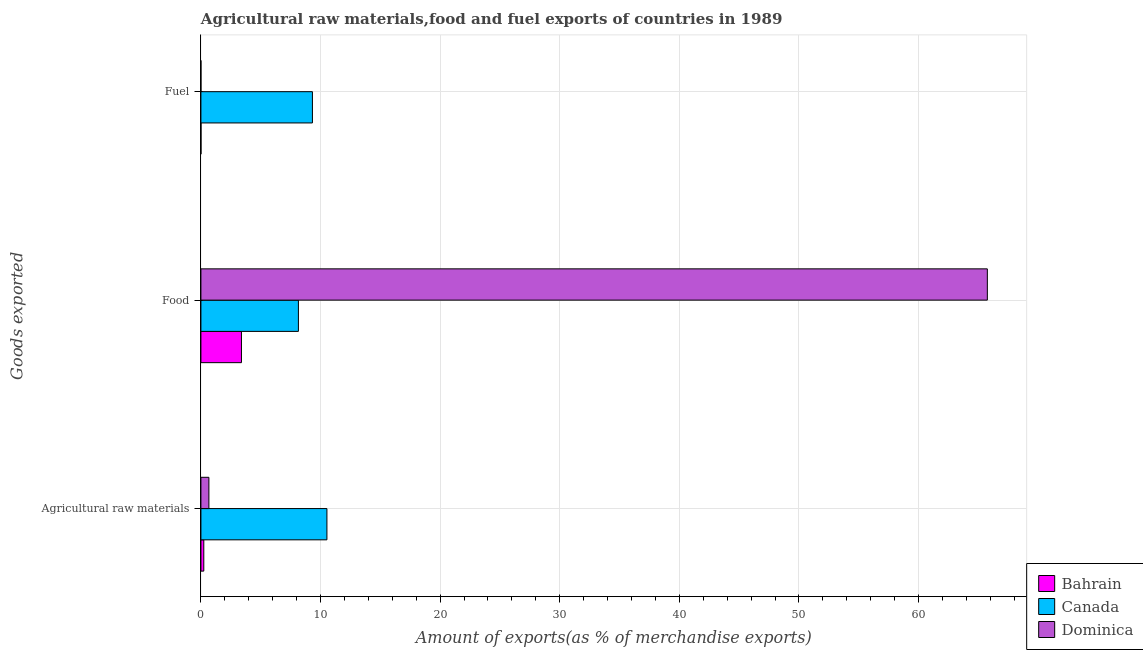How many different coloured bars are there?
Your answer should be very brief. 3. How many groups of bars are there?
Your answer should be compact. 3. What is the label of the 2nd group of bars from the top?
Provide a succinct answer. Food. What is the percentage of raw materials exports in Bahrain?
Your answer should be very brief. 0.24. Across all countries, what is the maximum percentage of fuel exports?
Ensure brevity in your answer.  9.32. Across all countries, what is the minimum percentage of raw materials exports?
Offer a terse response. 0.24. In which country was the percentage of fuel exports maximum?
Offer a terse response. Canada. In which country was the percentage of raw materials exports minimum?
Offer a very short reply. Bahrain. What is the total percentage of raw materials exports in the graph?
Your response must be concise. 11.44. What is the difference between the percentage of raw materials exports in Dominica and that in Bahrain?
Provide a short and direct response. 0.43. What is the difference between the percentage of fuel exports in Canada and the percentage of food exports in Bahrain?
Offer a very short reply. 5.93. What is the average percentage of raw materials exports per country?
Your response must be concise. 3.81. What is the difference between the percentage of fuel exports and percentage of food exports in Canada?
Make the answer very short. 1.17. What is the ratio of the percentage of food exports in Dominica to that in Canada?
Your answer should be compact. 8.07. Is the difference between the percentage of raw materials exports in Dominica and Canada greater than the difference between the percentage of fuel exports in Dominica and Canada?
Provide a short and direct response. No. What is the difference between the highest and the second highest percentage of food exports?
Offer a very short reply. 57.6. What is the difference between the highest and the lowest percentage of fuel exports?
Provide a succinct answer. 9.32. Is the sum of the percentage of fuel exports in Dominica and Bahrain greater than the maximum percentage of food exports across all countries?
Your answer should be very brief. No. What does the 3rd bar from the top in Food represents?
Keep it short and to the point. Bahrain. What does the 2nd bar from the bottom in Fuel represents?
Your answer should be very brief. Canada. Is it the case that in every country, the sum of the percentage of raw materials exports and percentage of food exports is greater than the percentage of fuel exports?
Ensure brevity in your answer.  Yes. How many countries are there in the graph?
Your response must be concise. 3. What is the difference between two consecutive major ticks on the X-axis?
Your response must be concise. 10. Are the values on the major ticks of X-axis written in scientific E-notation?
Keep it short and to the point. No. Does the graph contain grids?
Ensure brevity in your answer.  Yes. Where does the legend appear in the graph?
Give a very brief answer. Bottom right. How are the legend labels stacked?
Give a very brief answer. Vertical. What is the title of the graph?
Your answer should be very brief. Agricultural raw materials,food and fuel exports of countries in 1989. What is the label or title of the X-axis?
Provide a succinct answer. Amount of exports(as % of merchandise exports). What is the label or title of the Y-axis?
Give a very brief answer. Goods exported. What is the Amount of exports(as % of merchandise exports) of Bahrain in Agricultural raw materials?
Provide a succinct answer. 0.24. What is the Amount of exports(as % of merchandise exports) in Canada in Agricultural raw materials?
Give a very brief answer. 10.54. What is the Amount of exports(as % of merchandise exports) in Dominica in Agricultural raw materials?
Make the answer very short. 0.67. What is the Amount of exports(as % of merchandise exports) in Bahrain in Food?
Provide a short and direct response. 3.39. What is the Amount of exports(as % of merchandise exports) of Canada in Food?
Offer a very short reply. 8.15. What is the Amount of exports(as % of merchandise exports) of Dominica in Food?
Offer a very short reply. 65.75. What is the Amount of exports(as % of merchandise exports) in Bahrain in Fuel?
Provide a succinct answer. 0. What is the Amount of exports(as % of merchandise exports) of Canada in Fuel?
Give a very brief answer. 9.32. What is the Amount of exports(as % of merchandise exports) in Dominica in Fuel?
Offer a terse response. 3.67117277885959e-5. Across all Goods exported, what is the maximum Amount of exports(as % of merchandise exports) of Bahrain?
Your answer should be very brief. 3.39. Across all Goods exported, what is the maximum Amount of exports(as % of merchandise exports) of Canada?
Make the answer very short. 10.54. Across all Goods exported, what is the maximum Amount of exports(as % of merchandise exports) in Dominica?
Provide a succinct answer. 65.75. Across all Goods exported, what is the minimum Amount of exports(as % of merchandise exports) in Bahrain?
Provide a succinct answer. 0. Across all Goods exported, what is the minimum Amount of exports(as % of merchandise exports) in Canada?
Your answer should be compact. 8.15. Across all Goods exported, what is the minimum Amount of exports(as % of merchandise exports) in Dominica?
Your answer should be compact. 3.67117277885959e-5. What is the total Amount of exports(as % of merchandise exports) in Bahrain in the graph?
Ensure brevity in your answer.  3.64. What is the total Amount of exports(as % of merchandise exports) of Canada in the graph?
Give a very brief answer. 28.01. What is the total Amount of exports(as % of merchandise exports) of Dominica in the graph?
Offer a very short reply. 66.42. What is the difference between the Amount of exports(as % of merchandise exports) in Bahrain in Agricultural raw materials and that in Food?
Offer a very short reply. -3.15. What is the difference between the Amount of exports(as % of merchandise exports) in Canada in Agricultural raw materials and that in Food?
Offer a terse response. 2.38. What is the difference between the Amount of exports(as % of merchandise exports) of Dominica in Agricultural raw materials and that in Food?
Provide a short and direct response. -65.09. What is the difference between the Amount of exports(as % of merchandise exports) of Bahrain in Agricultural raw materials and that in Fuel?
Give a very brief answer. 0.24. What is the difference between the Amount of exports(as % of merchandise exports) of Canada in Agricultural raw materials and that in Fuel?
Ensure brevity in your answer.  1.21. What is the difference between the Amount of exports(as % of merchandise exports) in Dominica in Agricultural raw materials and that in Fuel?
Offer a very short reply. 0.67. What is the difference between the Amount of exports(as % of merchandise exports) of Bahrain in Food and that in Fuel?
Ensure brevity in your answer.  3.39. What is the difference between the Amount of exports(as % of merchandise exports) of Canada in Food and that in Fuel?
Provide a succinct answer. -1.17. What is the difference between the Amount of exports(as % of merchandise exports) of Dominica in Food and that in Fuel?
Offer a very short reply. 65.75. What is the difference between the Amount of exports(as % of merchandise exports) of Bahrain in Agricultural raw materials and the Amount of exports(as % of merchandise exports) of Canada in Food?
Provide a short and direct response. -7.91. What is the difference between the Amount of exports(as % of merchandise exports) in Bahrain in Agricultural raw materials and the Amount of exports(as % of merchandise exports) in Dominica in Food?
Offer a terse response. -65.51. What is the difference between the Amount of exports(as % of merchandise exports) of Canada in Agricultural raw materials and the Amount of exports(as % of merchandise exports) of Dominica in Food?
Keep it short and to the point. -55.22. What is the difference between the Amount of exports(as % of merchandise exports) in Bahrain in Agricultural raw materials and the Amount of exports(as % of merchandise exports) in Canada in Fuel?
Provide a succinct answer. -9.08. What is the difference between the Amount of exports(as % of merchandise exports) of Bahrain in Agricultural raw materials and the Amount of exports(as % of merchandise exports) of Dominica in Fuel?
Keep it short and to the point. 0.24. What is the difference between the Amount of exports(as % of merchandise exports) in Canada in Agricultural raw materials and the Amount of exports(as % of merchandise exports) in Dominica in Fuel?
Offer a very short reply. 10.54. What is the difference between the Amount of exports(as % of merchandise exports) in Bahrain in Food and the Amount of exports(as % of merchandise exports) in Canada in Fuel?
Ensure brevity in your answer.  -5.93. What is the difference between the Amount of exports(as % of merchandise exports) of Bahrain in Food and the Amount of exports(as % of merchandise exports) of Dominica in Fuel?
Offer a very short reply. 3.39. What is the difference between the Amount of exports(as % of merchandise exports) of Canada in Food and the Amount of exports(as % of merchandise exports) of Dominica in Fuel?
Your answer should be compact. 8.15. What is the average Amount of exports(as % of merchandise exports) in Bahrain per Goods exported?
Give a very brief answer. 1.21. What is the average Amount of exports(as % of merchandise exports) in Canada per Goods exported?
Offer a very short reply. 9.34. What is the average Amount of exports(as % of merchandise exports) of Dominica per Goods exported?
Your answer should be compact. 22.14. What is the difference between the Amount of exports(as % of merchandise exports) in Bahrain and Amount of exports(as % of merchandise exports) in Canada in Agricultural raw materials?
Make the answer very short. -10.29. What is the difference between the Amount of exports(as % of merchandise exports) of Bahrain and Amount of exports(as % of merchandise exports) of Dominica in Agricultural raw materials?
Provide a succinct answer. -0.43. What is the difference between the Amount of exports(as % of merchandise exports) of Canada and Amount of exports(as % of merchandise exports) of Dominica in Agricultural raw materials?
Keep it short and to the point. 9.87. What is the difference between the Amount of exports(as % of merchandise exports) of Bahrain and Amount of exports(as % of merchandise exports) of Canada in Food?
Your answer should be compact. -4.76. What is the difference between the Amount of exports(as % of merchandise exports) of Bahrain and Amount of exports(as % of merchandise exports) of Dominica in Food?
Offer a very short reply. -62.37. What is the difference between the Amount of exports(as % of merchandise exports) in Canada and Amount of exports(as % of merchandise exports) in Dominica in Food?
Your answer should be compact. -57.6. What is the difference between the Amount of exports(as % of merchandise exports) of Bahrain and Amount of exports(as % of merchandise exports) of Canada in Fuel?
Make the answer very short. -9.32. What is the difference between the Amount of exports(as % of merchandise exports) of Bahrain and Amount of exports(as % of merchandise exports) of Dominica in Fuel?
Your answer should be compact. 0. What is the difference between the Amount of exports(as % of merchandise exports) of Canada and Amount of exports(as % of merchandise exports) of Dominica in Fuel?
Your answer should be very brief. 9.32. What is the ratio of the Amount of exports(as % of merchandise exports) in Bahrain in Agricultural raw materials to that in Food?
Provide a short and direct response. 0.07. What is the ratio of the Amount of exports(as % of merchandise exports) of Canada in Agricultural raw materials to that in Food?
Provide a succinct answer. 1.29. What is the ratio of the Amount of exports(as % of merchandise exports) of Dominica in Agricultural raw materials to that in Food?
Provide a succinct answer. 0.01. What is the ratio of the Amount of exports(as % of merchandise exports) in Bahrain in Agricultural raw materials to that in Fuel?
Your answer should be compact. 56.05. What is the ratio of the Amount of exports(as % of merchandise exports) in Canada in Agricultural raw materials to that in Fuel?
Your answer should be compact. 1.13. What is the ratio of the Amount of exports(as % of merchandise exports) in Dominica in Agricultural raw materials to that in Fuel?
Give a very brief answer. 1.82e+04. What is the ratio of the Amount of exports(as % of merchandise exports) in Bahrain in Food to that in Fuel?
Offer a very short reply. 787.43. What is the ratio of the Amount of exports(as % of merchandise exports) in Canada in Food to that in Fuel?
Your answer should be compact. 0.87. What is the ratio of the Amount of exports(as % of merchandise exports) of Dominica in Food to that in Fuel?
Your answer should be very brief. 1.79e+06. What is the difference between the highest and the second highest Amount of exports(as % of merchandise exports) in Bahrain?
Your answer should be very brief. 3.15. What is the difference between the highest and the second highest Amount of exports(as % of merchandise exports) of Canada?
Your answer should be compact. 1.21. What is the difference between the highest and the second highest Amount of exports(as % of merchandise exports) of Dominica?
Offer a terse response. 65.09. What is the difference between the highest and the lowest Amount of exports(as % of merchandise exports) of Bahrain?
Offer a very short reply. 3.39. What is the difference between the highest and the lowest Amount of exports(as % of merchandise exports) of Canada?
Offer a terse response. 2.38. What is the difference between the highest and the lowest Amount of exports(as % of merchandise exports) of Dominica?
Keep it short and to the point. 65.75. 